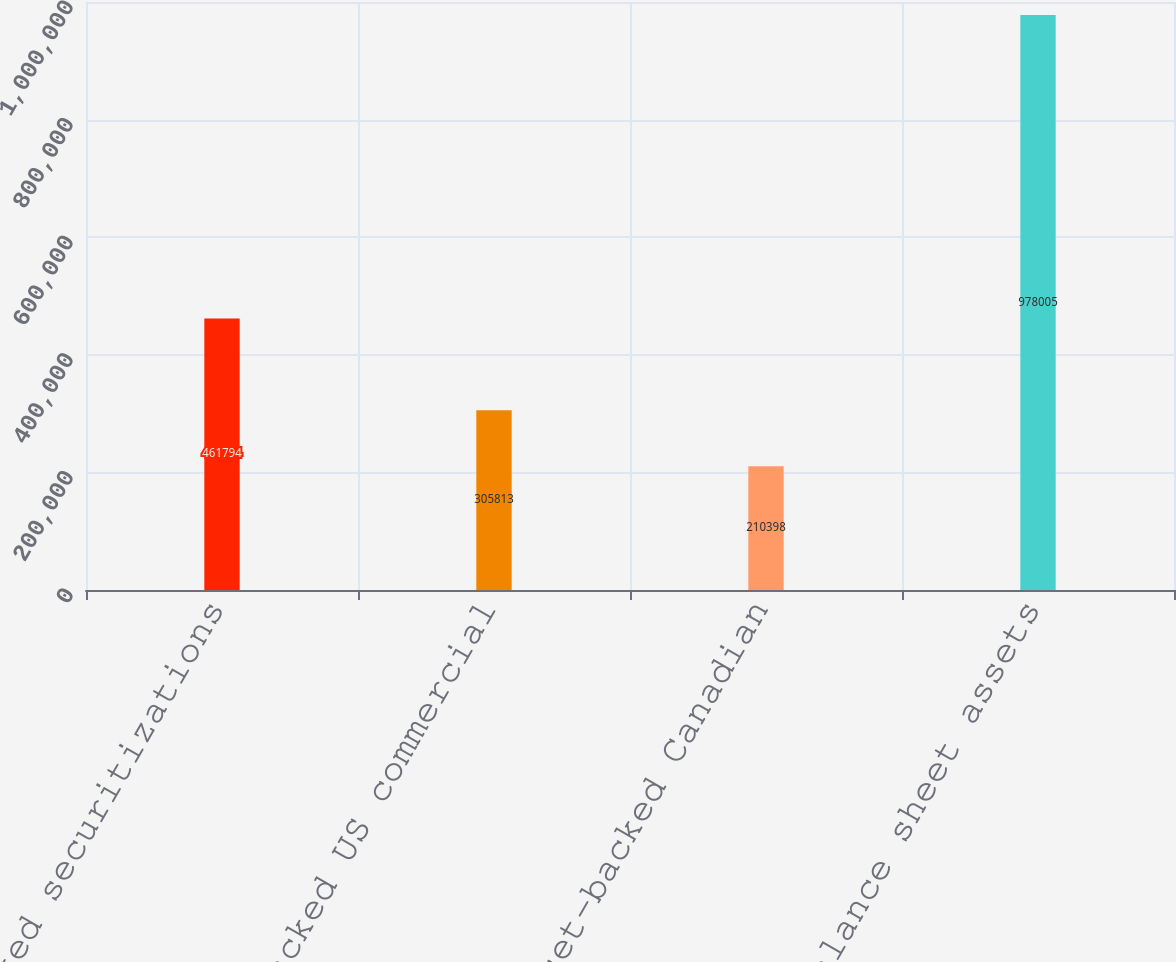Convert chart to OTSL. <chart><loc_0><loc_0><loc_500><loc_500><bar_chart><fcel>Asset-backed securitizations<fcel>Asset-backed US commercial<fcel>Asset-backed Canadian<fcel>Total on-balance sheet assets<nl><fcel>461794<fcel>305813<fcel>210398<fcel>978005<nl></chart> 